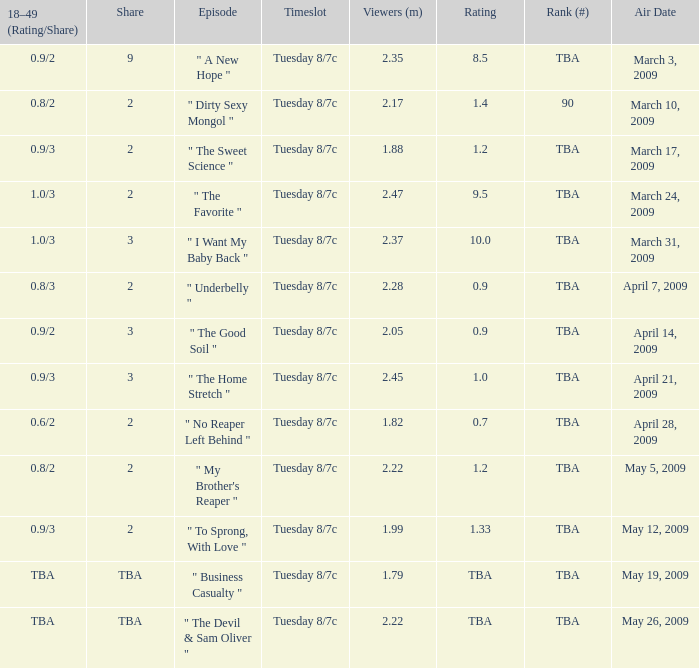Regarding the show with a tba ranking that was aired on april 21, 2009, what is its given rating? 1.0. 